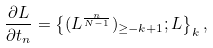<formula> <loc_0><loc_0><loc_500><loc_500>\frac { \partial L } { \partial t _ { n } } = \left \{ ( L ^ { \frac { n } { N - 1 } } ) _ { \geq - k + 1 } ; L \right \} _ { k } ,</formula> 